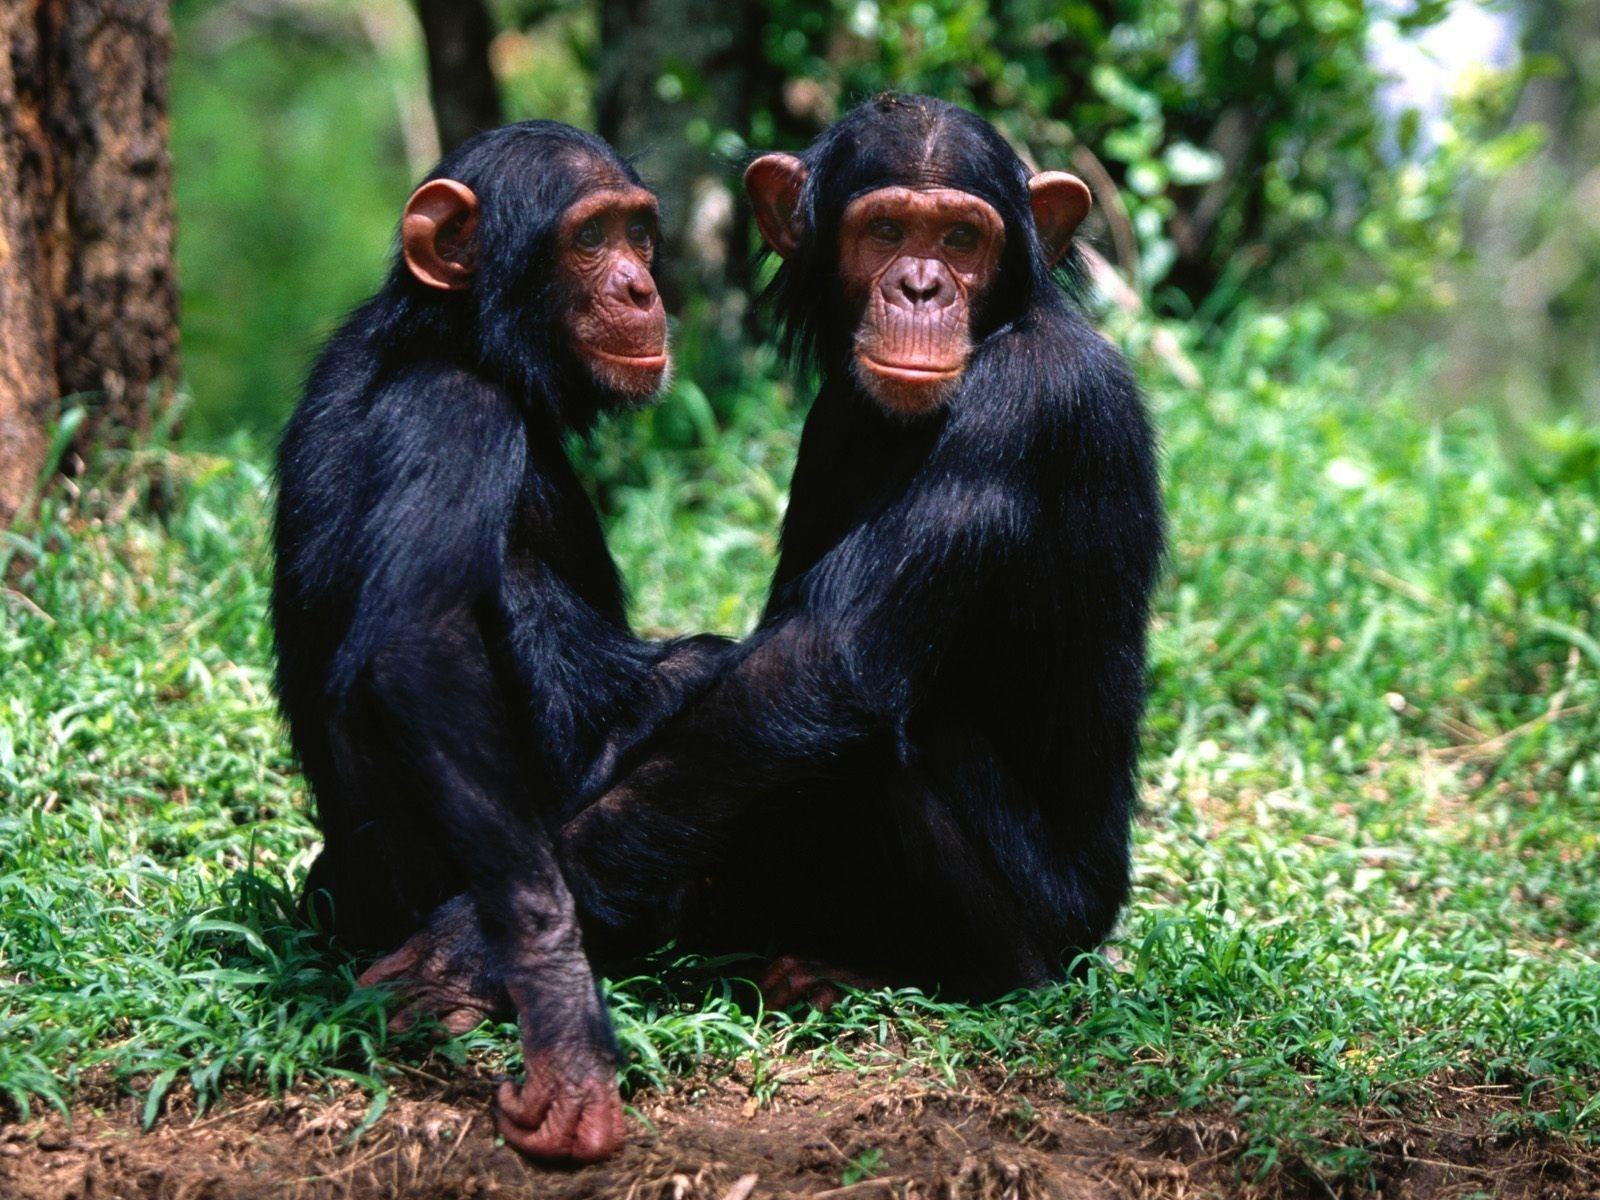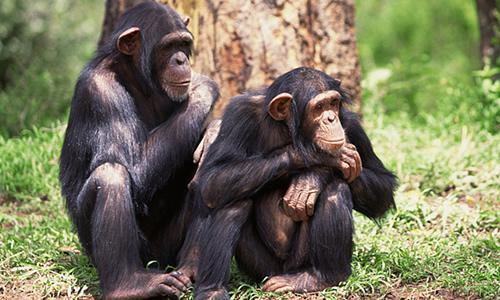The first image is the image on the left, the second image is the image on the right. Considering the images on both sides, is "There are four apes" valid? Answer yes or no. Yes. 